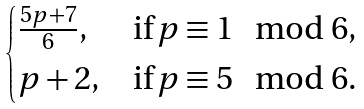Convert formula to latex. <formula><loc_0><loc_0><loc_500><loc_500>\begin{cases} \frac { 5 p + 7 } 6 , & \text {if} \, p \equiv 1 \mod 6 , \\ p + 2 , & \text {if} \, p \equiv 5 \mod 6 . \end{cases}</formula> 